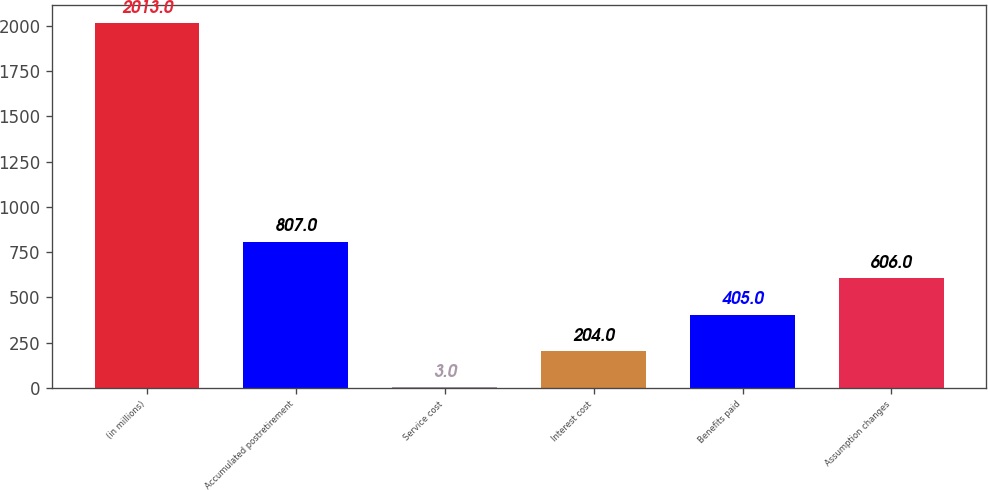Convert chart. <chart><loc_0><loc_0><loc_500><loc_500><bar_chart><fcel>(in millions)<fcel>Accumulated postretirement<fcel>Service cost<fcel>Interest cost<fcel>Benefits paid<fcel>Assumption changes<nl><fcel>2013<fcel>807<fcel>3<fcel>204<fcel>405<fcel>606<nl></chart> 